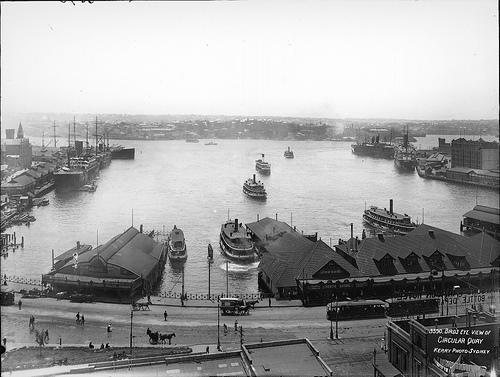How many boats are in the photo?
Give a very brief answer. 2. 